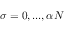Convert formula to latex. <formula><loc_0><loc_0><loc_500><loc_500>\sigma = 0 , \dots , \alpha N</formula> 